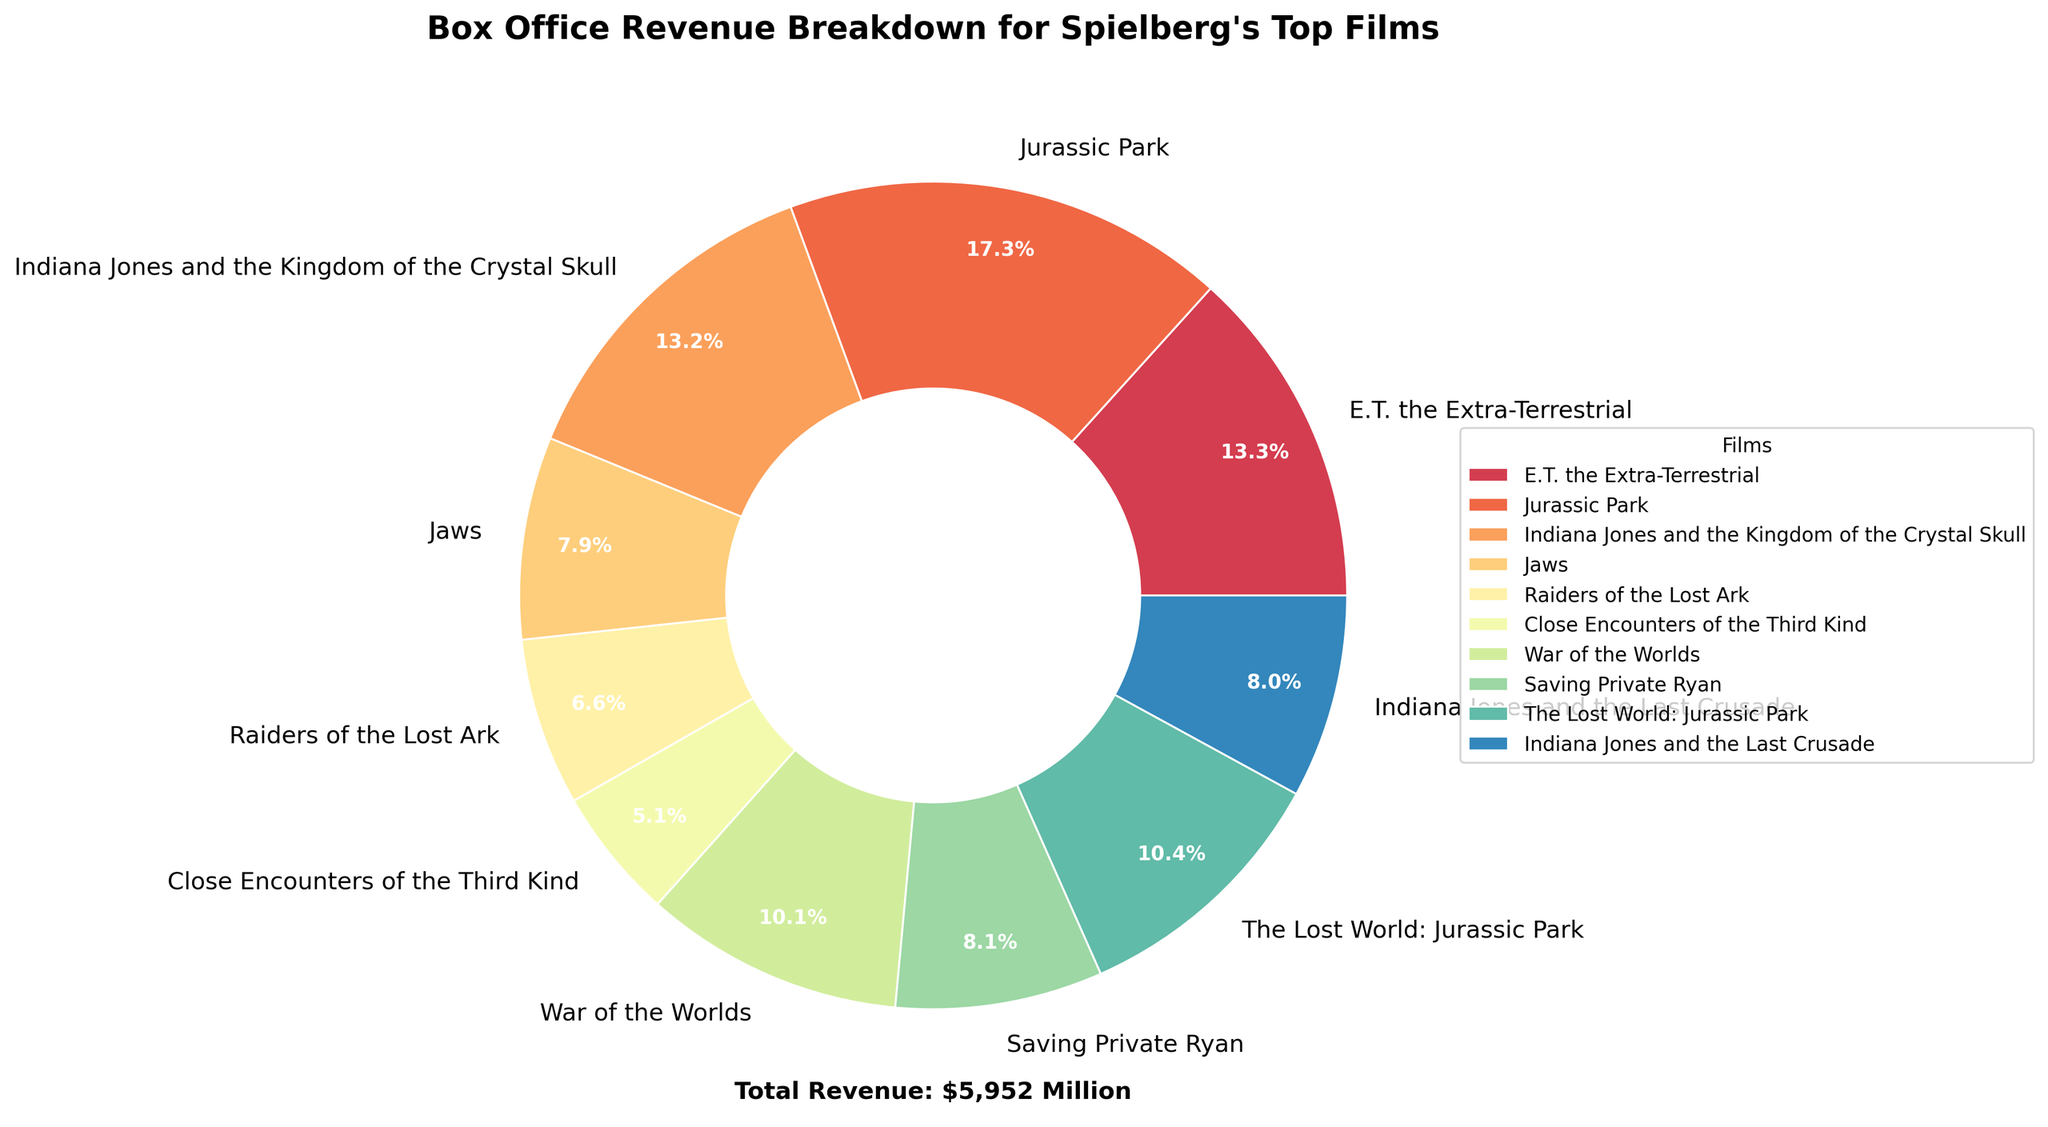What's the percentage of revenue generated by 'Jurassic Park'? Look at the pie chart and find the section labeled 'Jurassic Park'. The percentage is usually displayed next to the label.
Answer: `26.3%` Which film has the smallest contribution to the total revenue? Identify the smallest wedge in the pie chart. The label next to this wedge will indicate the film with the smallest contribution.
Answer: `Raiders of the Lost Ark` What is the total box office revenue of the films that earned less than $500 million? Identify the films which have revenue listed below $500 million - 'Jaws' ($471M), 'Raiders of the Lost Ark' ($390M), 'Close Encounters of the Third Kind' ($306M), and 'Indiana Jones and the Last Crusade' ($474M). Add these revenues together: 471 + 390 + 306 + 474. The sum is the total box office revenue.
Answer: `$1,641M` How much more did 'Jurassic Park' earn compared to 'Indiana Jones and the Kingdom of the Crystal Skull'? Locate the revenues for both films: 'Jurassic Park' ($1029M) and 'Indiana Jones and the Kingdom of the Crystal Skull' ($786M). Subtract the latter from the former to find the difference. 1029 - 786.
Answer: `$243M` Which films collectively account for more than 50% of the total box office revenue? Identify the films whose combined sections make up more than half of the pie chart (more than 50%). From the chart, sum the percentages until you surpass 50%. 'Jurassic Park' (26.3%), 'E.T. the Extra-Terrestrial' (20.3%), and part of 'War of the Worlds' contribute to the exceeding sum.
Answer: `Jurassic Park, E.T. the Extra-Terrestrial, and War of the Worlds` What is the average box office revenue of the top 5 highest-grossing films? Identify the top 5 films by their revenue from the data or pie chart: 'Jurassic Park' ($1029M), 'E.T. the Extra-Terrestrial' ($792M), 'Indiana Jones and the Kingdom of the Crystal Skull' ($786M), 'War of the Worlds' ($603M), and 'The Lost World: Jurassic Park' ($619M). Sum these revenues and then divide by 5 to find the average. 1029 + 792 + 786 + 603 + 619 = 3829 / 5.
Answer: `$765.8M` What is the percentage difference in revenue between the highest-grossing and lowest-grossing films? Identify the highest ('Jurassic Park' - $1029M) and the lowest ('Raiders of the Lost Ark' - $390M) revenues from the data. Compute the percentage difference by dividing the difference between these two numbers by the highest revenue, then multiply by 100. (1029 - 390) / 1029 * 100.
Answer: `62.1%` Which film occupies the largest portion of the pie chart? Look at the pie chart and focus on the wedge that appears the largest by area or percentage displayed next to it.
Answer: 'Jurassic Park' If 'Jurassic Park' and 'E.T. the Extra-Terrestrial' combined their revenues, what percentage of the total would they represent? Find the sum of 'Jurassic Park' ($1029M) and 'E.T. the Extra-Terrestrial' ($792M) which is 1029 + 792 = 1821M. The total revenue from the section 'Add total revenue' is $6582M. Then, calculate the percentage: 1821 / 6582 * 100.
Answer: `27.7%` What is the visual indicator used to differentiate the films in the pie chart? Identify the primary visual cue used to distinguish each section of the pie chart, such as colors or patterns.
Answer: `Colors` 